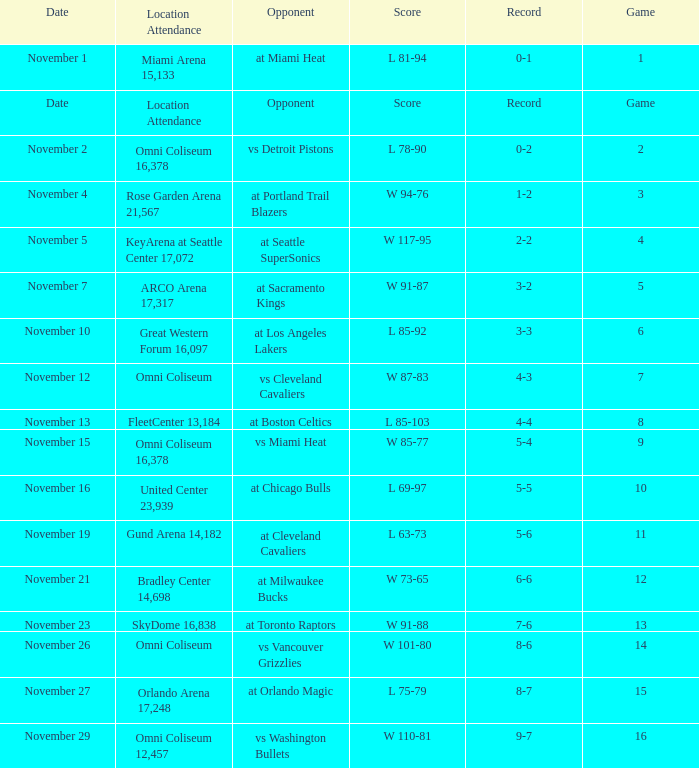Who was their opponent in game 4? At seattle supersonics. 